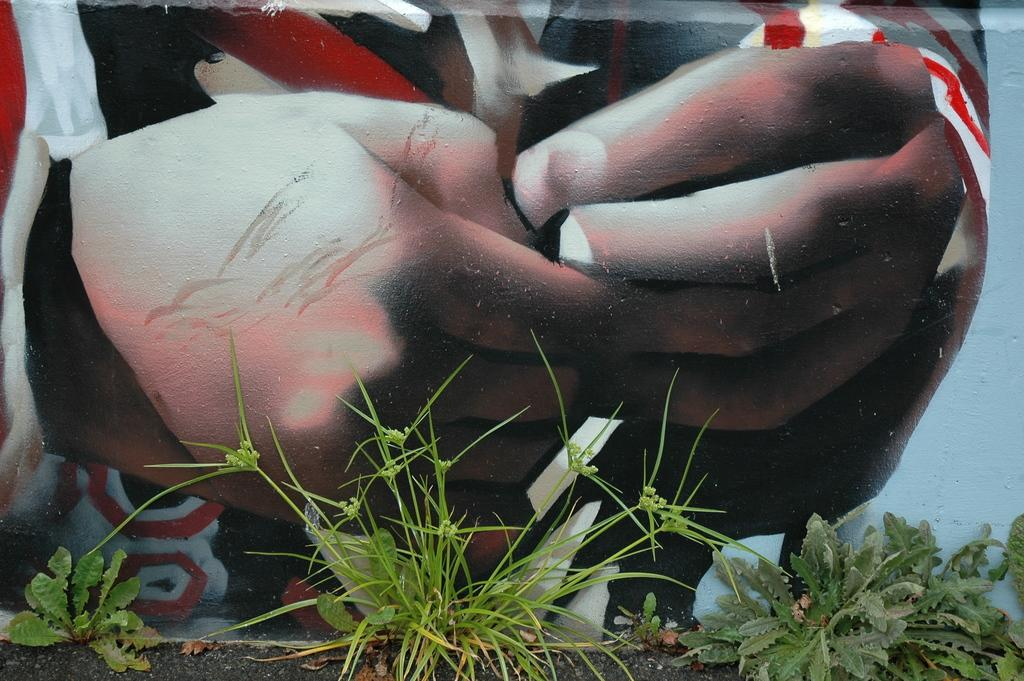What is located at the bottom of the image? There are plants at the bottom of the image. What can be seen in the background of the image? There is a painting on a wall in the background of the image. What type of popcorn is being served in the image? There is no popcorn present in the image. Can you describe the veins in the painting in the image? There is no mention of veins in the painting or any other part of the image. 